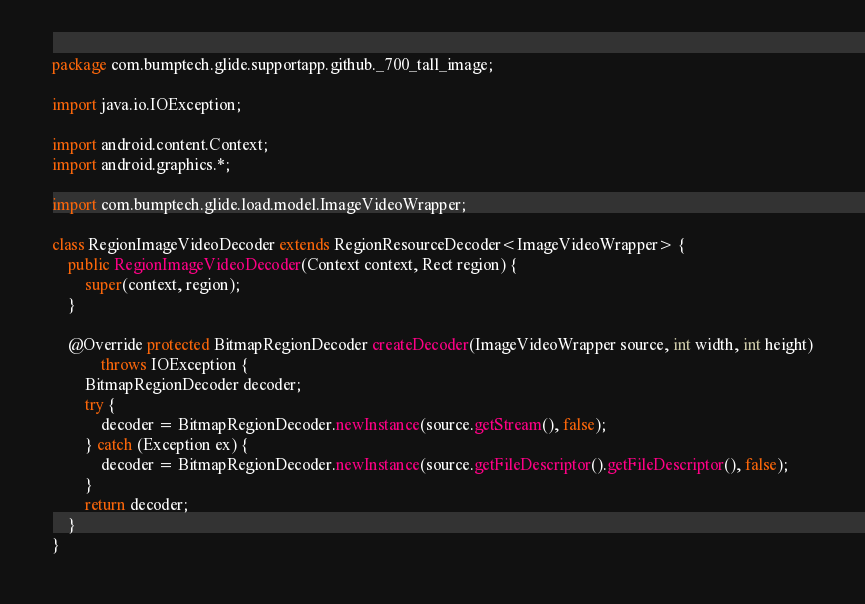<code> <loc_0><loc_0><loc_500><loc_500><_Java_>package com.bumptech.glide.supportapp.github._700_tall_image;

import java.io.IOException;

import android.content.Context;
import android.graphics.*;

import com.bumptech.glide.load.model.ImageVideoWrapper;

class RegionImageVideoDecoder extends RegionResourceDecoder<ImageVideoWrapper> {
	public RegionImageVideoDecoder(Context context, Rect region) {
		super(context, region);
	}

	@Override protected BitmapRegionDecoder createDecoder(ImageVideoWrapper source, int width, int height)
			throws IOException {
		BitmapRegionDecoder decoder;
		try {
			decoder = BitmapRegionDecoder.newInstance(source.getStream(), false);
		} catch (Exception ex) {
			decoder = BitmapRegionDecoder.newInstance(source.getFileDescriptor().getFileDescriptor(), false);
		}
		return decoder;
	}
}
</code> 